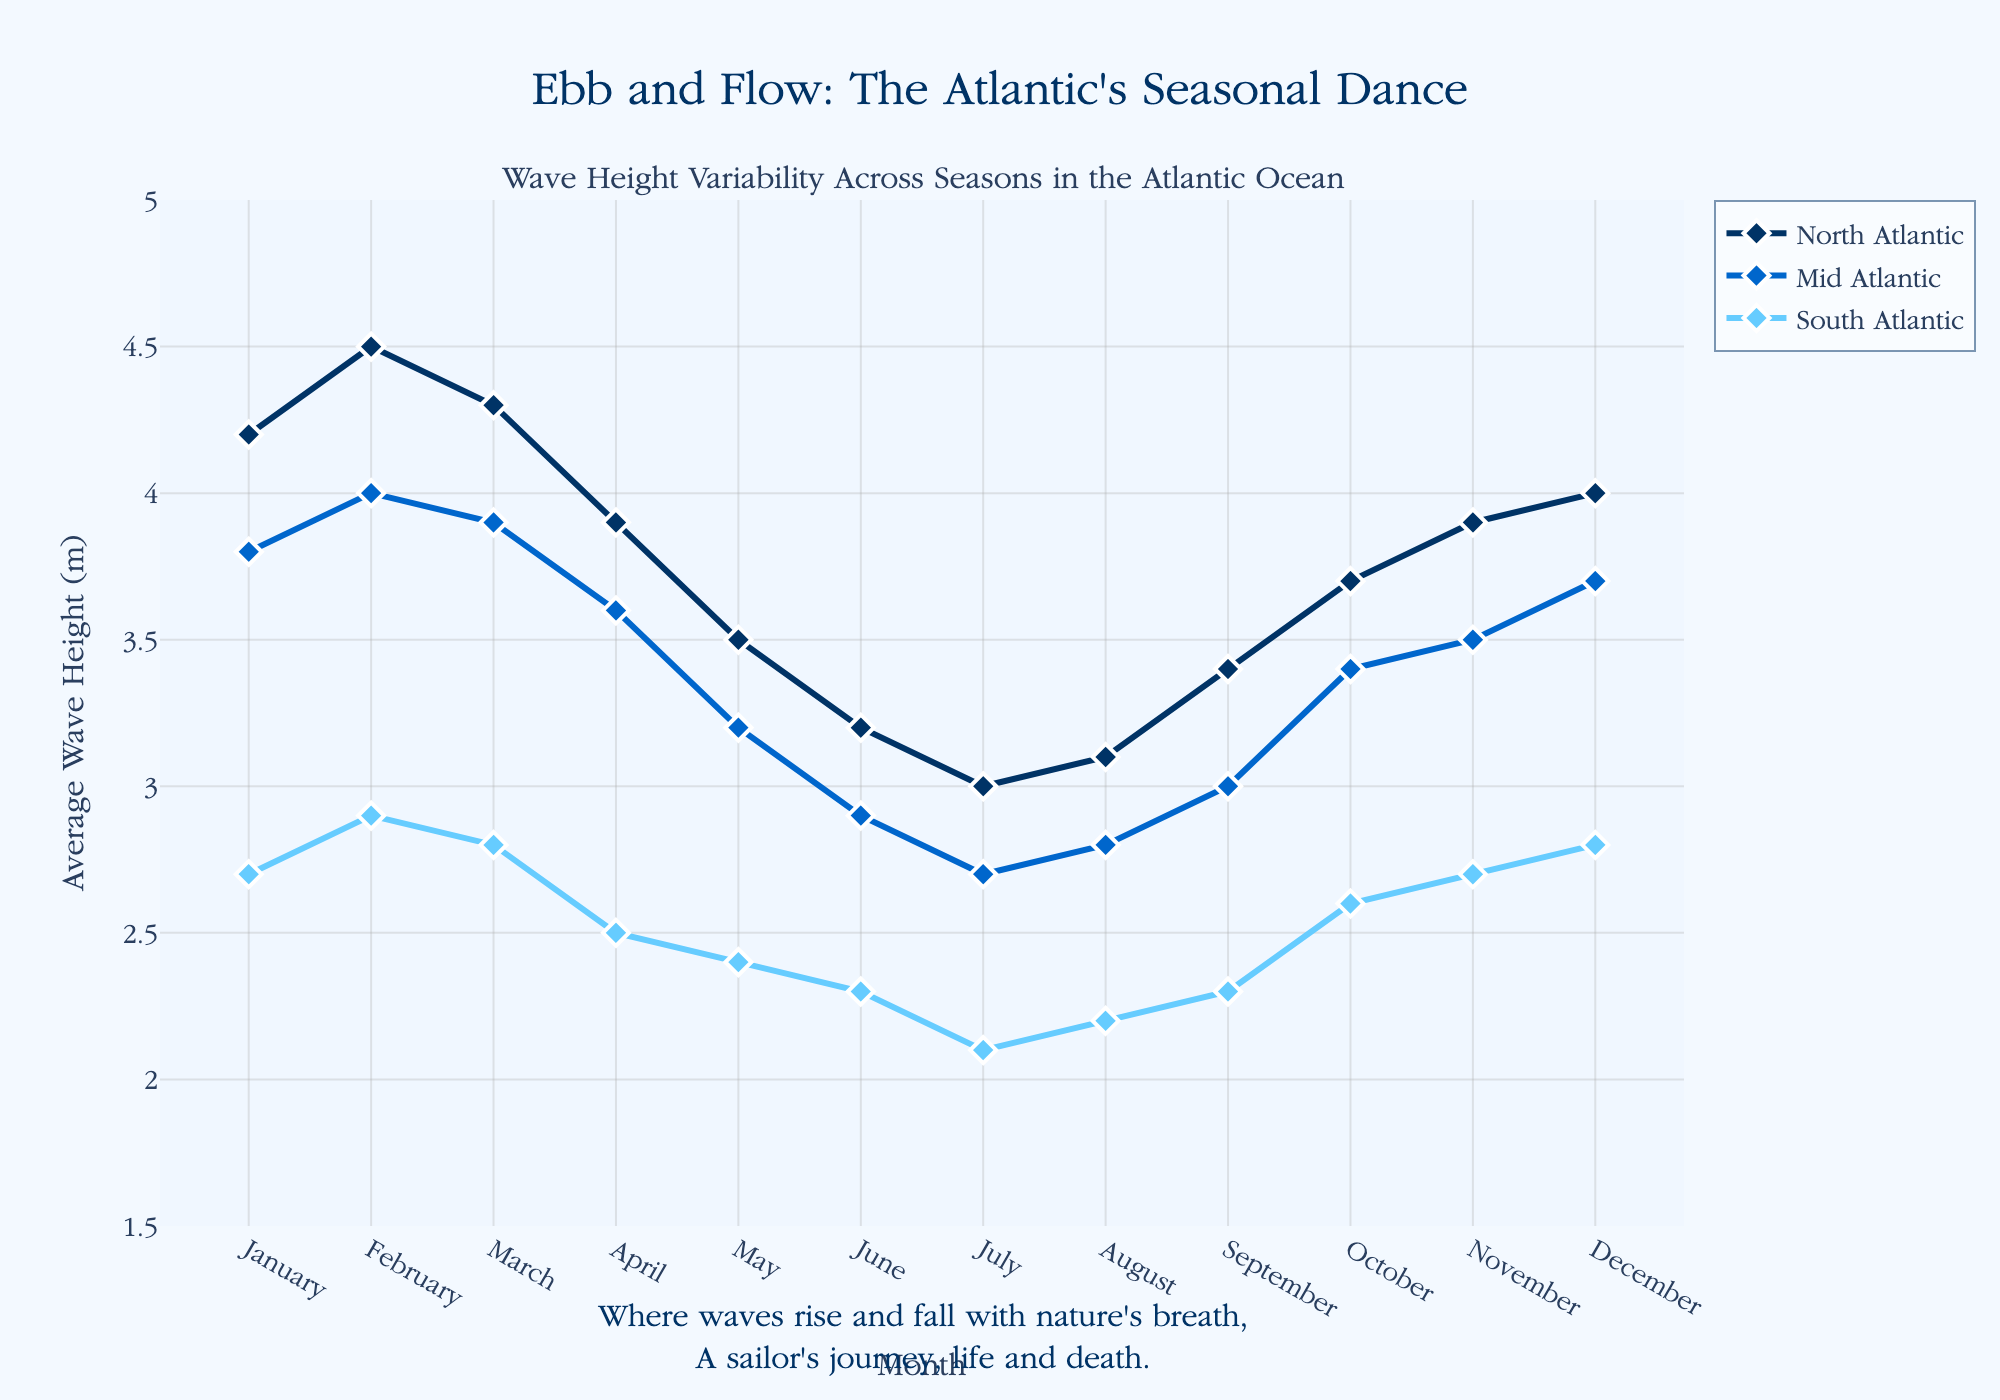What's the title of the figure? The title is usually located at the top of the figure. In this case, the title given in the code is "Ebb and Flow: The Atlantic's Seasonal Dance".
Answer: Ebb and Flow: The Atlantic's Seasonal Dance Which region experiences the highest average wave height in January? Look at the January data points for each region and compare their wave heights. The North Atlantic has the highest with 4.2 meters.
Answer: North Atlantic How does the average wave height in the South Atlantic change from January to July? Observe the data points for the South Atlantic from January to July. In January, the wave height is 2.7 meters. By July, it has decreased to 2.1 meters.
Answer: It decreases In which month does the Mid Atlantic see its highest average wave height? Identify the peak value in the Mid Atlantic data points and note the corresponding month. The highest is in February with 4.0 meters.
Answer: February Compare the average wave heights between the North Atlantic and South Atlantic in October. Which region has a higher average wave height, and by how much? Locate the October data points for both regions. The North Atlantic has 3.7 meters and the South Atlantic has 2.6 meters. Subtract to find the difference: 3.7 - 2.6 = 1.1 meters.
Answer: North Atlantic by 1.1 meters What is the overall trend of wave height variability in the North Atlantic from January to December? Track the changes in wave height for the North Atlantic across all months. The heights start high in January, dip towards July, then rise again towards December.
Answer: Decreases then increases During which month(s) do all three regions have their lowest average wave heights? Look for the lowest point in each region and see if any months have the lowest values for all regions. In July, North Atlantic (3.0), Mid Atlantic (2.7), and South Atlantic (2.1) are at their lowest.
Answer: July Calculate the difference in average wave height between North Atlantic and Mid Atlantic in March. Find the March data points for both regions and subtract to find the difference. North Atlantic has 4.3 meters, and Mid Atlantic has 3.9 meters. So, 4.3 - 3.9 = 0.4 meters.
Answer: 0.4 meters What can you infer about the seasonal pattern of wave heights in the South Atlantic? Observe the South Atlantic data points across the months. The pattern shows a gradual decrease from January to July, followed by a slight increase towards December.
Answer: Decreases then slightly increases 